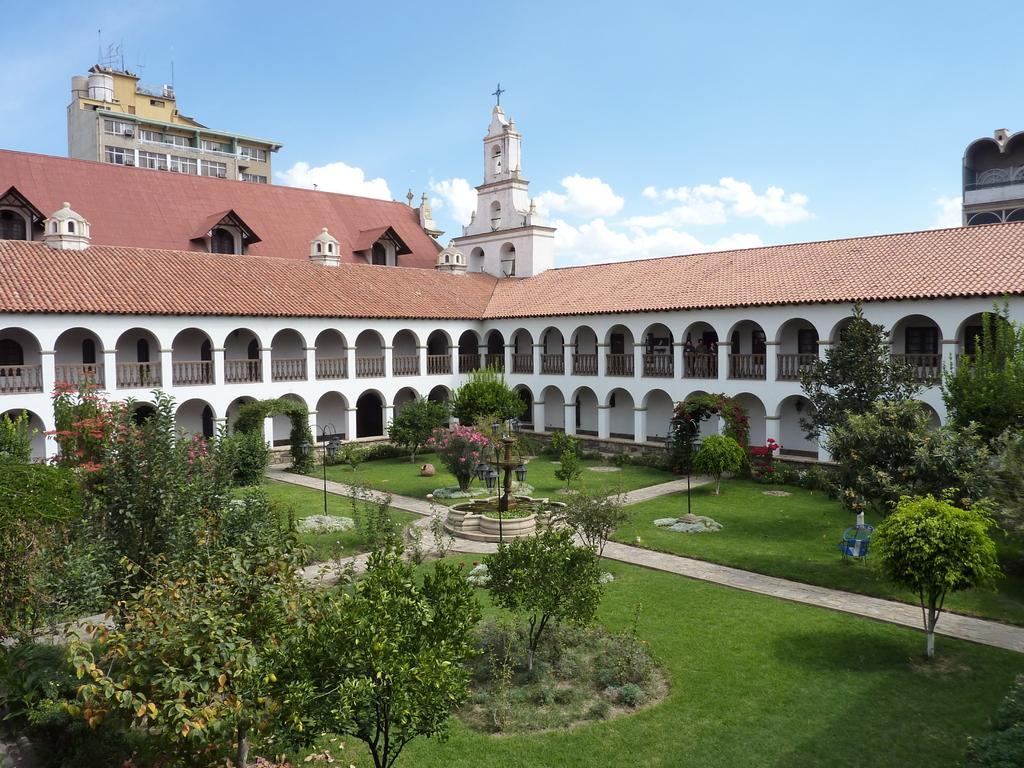How would you summarize this image in a sentence or two? In this image we can see some trees, walkway, lamps, fountain and at the background of the image there is building, church and clear sky. 